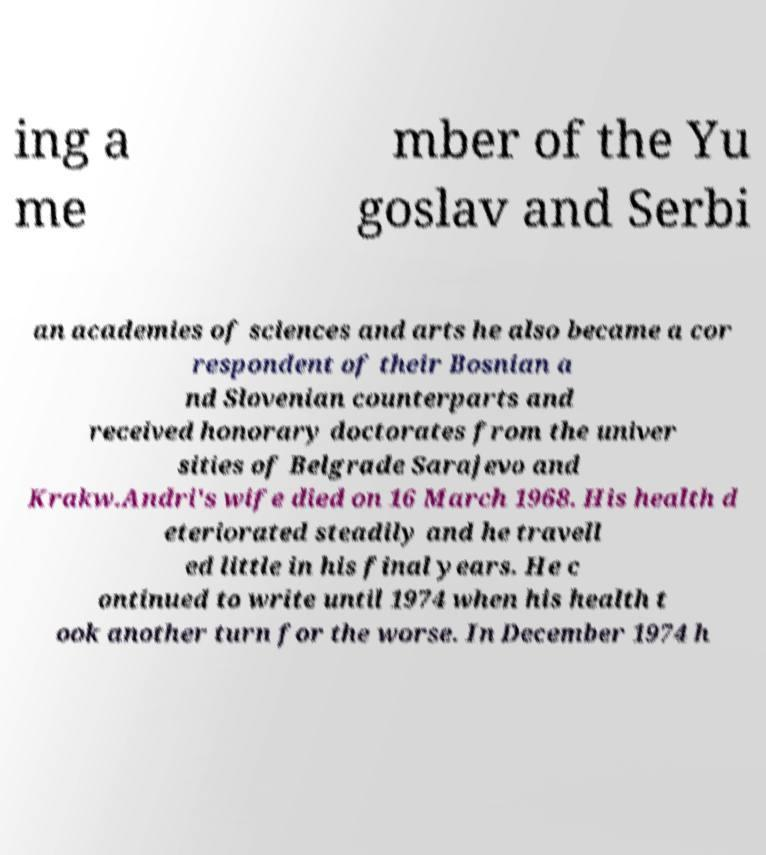For documentation purposes, I need the text within this image transcribed. Could you provide that? ing a me mber of the Yu goslav and Serbi an academies of sciences and arts he also became a cor respondent of their Bosnian a nd Slovenian counterparts and received honorary doctorates from the univer sities of Belgrade Sarajevo and Krakw.Andri's wife died on 16 March 1968. His health d eteriorated steadily and he travell ed little in his final years. He c ontinued to write until 1974 when his health t ook another turn for the worse. In December 1974 h 